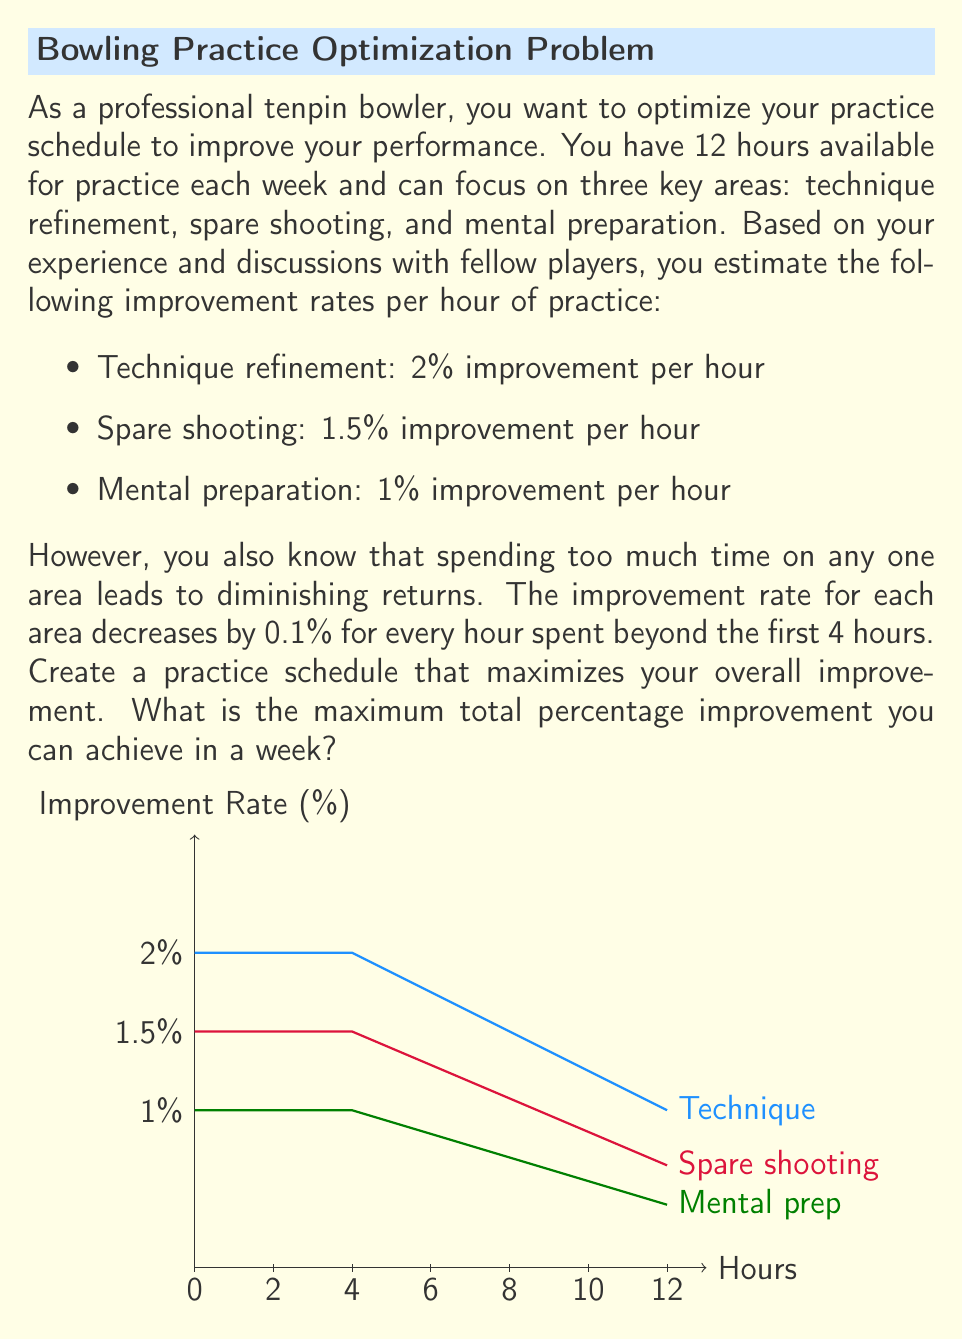Give your solution to this math problem. To solve this optimization problem, we'll follow these steps:

1) First, let's define our variables:
   $x$ = hours spent on technique refinement
   $y$ = hours spent on spare shooting
   $z$ = hours spent on mental preparation

2) Our constraint is:
   $x + y + z = 12$ (total available hours)

3) Now, let's define the improvement function for each area:
   For $x \leq 4$: $f_1(x) = 2x$
   For $x > 4$: $f_1(x) = 8 + 1.9(x-4) + 1.8(x-5) + 1.7(x-6) + ...$
   
   Similar functions apply for $y$ and $z$ with their respective initial rates.

4) Our objective function to maximize is:
   $F(x,y,z) = f_1(x) + f_2(y) + f_3(z)$

5) Given the diminishing returns, it's optimal to distribute hours more evenly rather than focusing on one area.

6) Let's try allocating hours close to evenly:
   $x = 5, y = 4, z = 3$

   Improvement from technique: $8 + 1.9 = 9.9\%$
   Improvement from spare shooting: $6\%$
   Improvement from mental prep: $3\%$

   Total: $18.9\%$

7) We can slightly adjust this:
   $x = 5, y = 5, z = 2$

   Improvement from technique: $9.9\%$
   Improvement from spare shooting: $7.4\%$
   Improvement from mental prep: $2\%$

   Total: $19.3\%$

8) Further adjustments don't yield better results, so this appears to be the optimal allocation.
Answer: 19.3% 